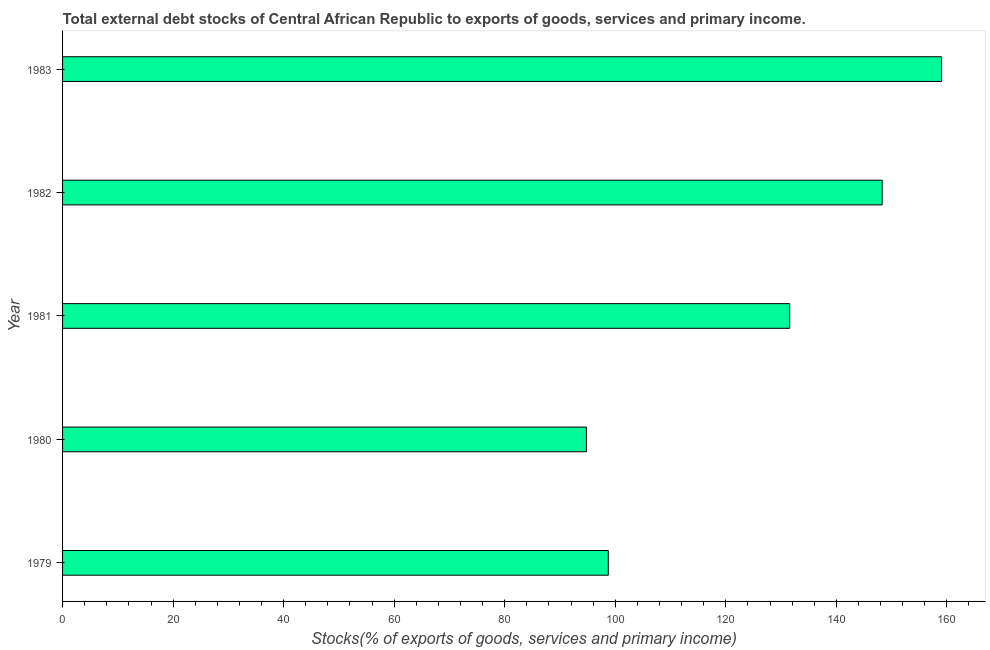What is the title of the graph?
Make the answer very short. Total external debt stocks of Central African Republic to exports of goods, services and primary income. What is the label or title of the X-axis?
Provide a succinct answer. Stocks(% of exports of goods, services and primary income). What is the label or title of the Y-axis?
Your answer should be very brief. Year. What is the external debt stocks in 1981?
Make the answer very short. 131.57. Across all years, what is the maximum external debt stocks?
Provide a succinct answer. 159.03. Across all years, what is the minimum external debt stocks?
Offer a terse response. 94.78. In which year was the external debt stocks minimum?
Provide a short and direct response. 1980. What is the sum of the external debt stocks?
Your response must be concise. 632.41. What is the difference between the external debt stocks in 1981 and 1983?
Give a very brief answer. -27.47. What is the average external debt stocks per year?
Provide a short and direct response. 126.48. What is the median external debt stocks?
Your response must be concise. 131.57. Do a majority of the years between 1983 and 1980 (inclusive) have external debt stocks greater than 152 %?
Make the answer very short. Yes. What is the ratio of the external debt stocks in 1981 to that in 1983?
Your response must be concise. 0.83. Is the external debt stocks in 1979 less than that in 1980?
Your answer should be compact. No. Is the difference between the external debt stocks in 1979 and 1981 greater than the difference between any two years?
Ensure brevity in your answer.  No. What is the difference between the highest and the second highest external debt stocks?
Offer a very short reply. 10.74. Is the sum of the external debt stocks in 1980 and 1981 greater than the maximum external debt stocks across all years?
Your response must be concise. Yes. What is the difference between the highest and the lowest external debt stocks?
Make the answer very short. 64.25. How many bars are there?
Your answer should be very brief. 5. How many years are there in the graph?
Offer a terse response. 5. What is the difference between two consecutive major ticks on the X-axis?
Your response must be concise. 20. Are the values on the major ticks of X-axis written in scientific E-notation?
Keep it short and to the point. No. What is the Stocks(% of exports of goods, services and primary income) of 1979?
Provide a short and direct response. 98.74. What is the Stocks(% of exports of goods, services and primary income) in 1980?
Keep it short and to the point. 94.78. What is the Stocks(% of exports of goods, services and primary income) in 1981?
Provide a succinct answer. 131.57. What is the Stocks(% of exports of goods, services and primary income) of 1982?
Make the answer very short. 148.29. What is the Stocks(% of exports of goods, services and primary income) in 1983?
Give a very brief answer. 159.03. What is the difference between the Stocks(% of exports of goods, services and primary income) in 1979 and 1980?
Provide a succinct answer. 3.96. What is the difference between the Stocks(% of exports of goods, services and primary income) in 1979 and 1981?
Give a very brief answer. -32.83. What is the difference between the Stocks(% of exports of goods, services and primary income) in 1979 and 1982?
Give a very brief answer. -49.55. What is the difference between the Stocks(% of exports of goods, services and primary income) in 1979 and 1983?
Your answer should be compact. -60.29. What is the difference between the Stocks(% of exports of goods, services and primary income) in 1980 and 1981?
Your answer should be compact. -36.79. What is the difference between the Stocks(% of exports of goods, services and primary income) in 1980 and 1982?
Make the answer very short. -53.51. What is the difference between the Stocks(% of exports of goods, services and primary income) in 1980 and 1983?
Provide a succinct answer. -64.25. What is the difference between the Stocks(% of exports of goods, services and primary income) in 1981 and 1982?
Your answer should be compact. -16.72. What is the difference between the Stocks(% of exports of goods, services and primary income) in 1981 and 1983?
Provide a short and direct response. -27.47. What is the difference between the Stocks(% of exports of goods, services and primary income) in 1982 and 1983?
Provide a succinct answer. -10.75. What is the ratio of the Stocks(% of exports of goods, services and primary income) in 1979 to that in 1980?
Ensure brevity in your answer.  1.04. What is the ratio of the Stocks(% of exports of goods, services and primary income) in 1979 to that in 1981?
Offer a terse response. 0.75. What is the ratio of the Stocks(% of exports of goods, services and primary income) in 1979 to that in 1982?
Keep it short and to the point. 0.67. What is the ratio of the Stocks(% of exports of goods, services and primary income) in 1979 to that in 1983?
Keep it short and to the point. 0.62. What is the ratio of the Stocks(% of exports of goods, services and primary income) in 1980 to that in 1981?
Provide a short and direct response. 0.72. What is the ratio of the Stocks(% of exports of goods, services and primary income) in 1980 to that in 1982?
Your answer should be compact. 0.64. What is the ratio of the Stocks(% of exports of goods, services and primary income) in 1980 to that in 1983?
Provide a succinct answer. 0.6. What is the ratio of the Stocks(% of exports of goods, services and primary income) in 1981 to that in 1982?
Keep it short and to the point. 0.89. What is the ratio of the Stocks(% of exports of goods, services and primary income) in 1981 to that in 1983?
Your answer should be compact. 0.83. What is the ratio of the Stocks(% of exports of goods, services and primary income) in 1982 to that in 1983?
Offer a terse response. 0.93. 